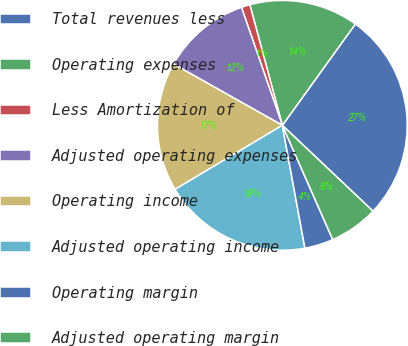<chart> <loc_0><loc_0><loc_500><loc_500><pie_chart><fcel>Total revenues less<fcel>Operating expenses<fcel>Less Amortization of<fcel>Adjusted operating expenses<fcel>Operating income<fcel>Adjusted operating income<fcel>Operating margin<fcel>Adjusted operating margin<nl><fcel>27.13%<fcel>14.13%<fcel>1.12%<fcel>11.53%<fcel>16.73%<fcel>19.33%<fcel>3.72%<fcel>6.32%<nl></chart> 